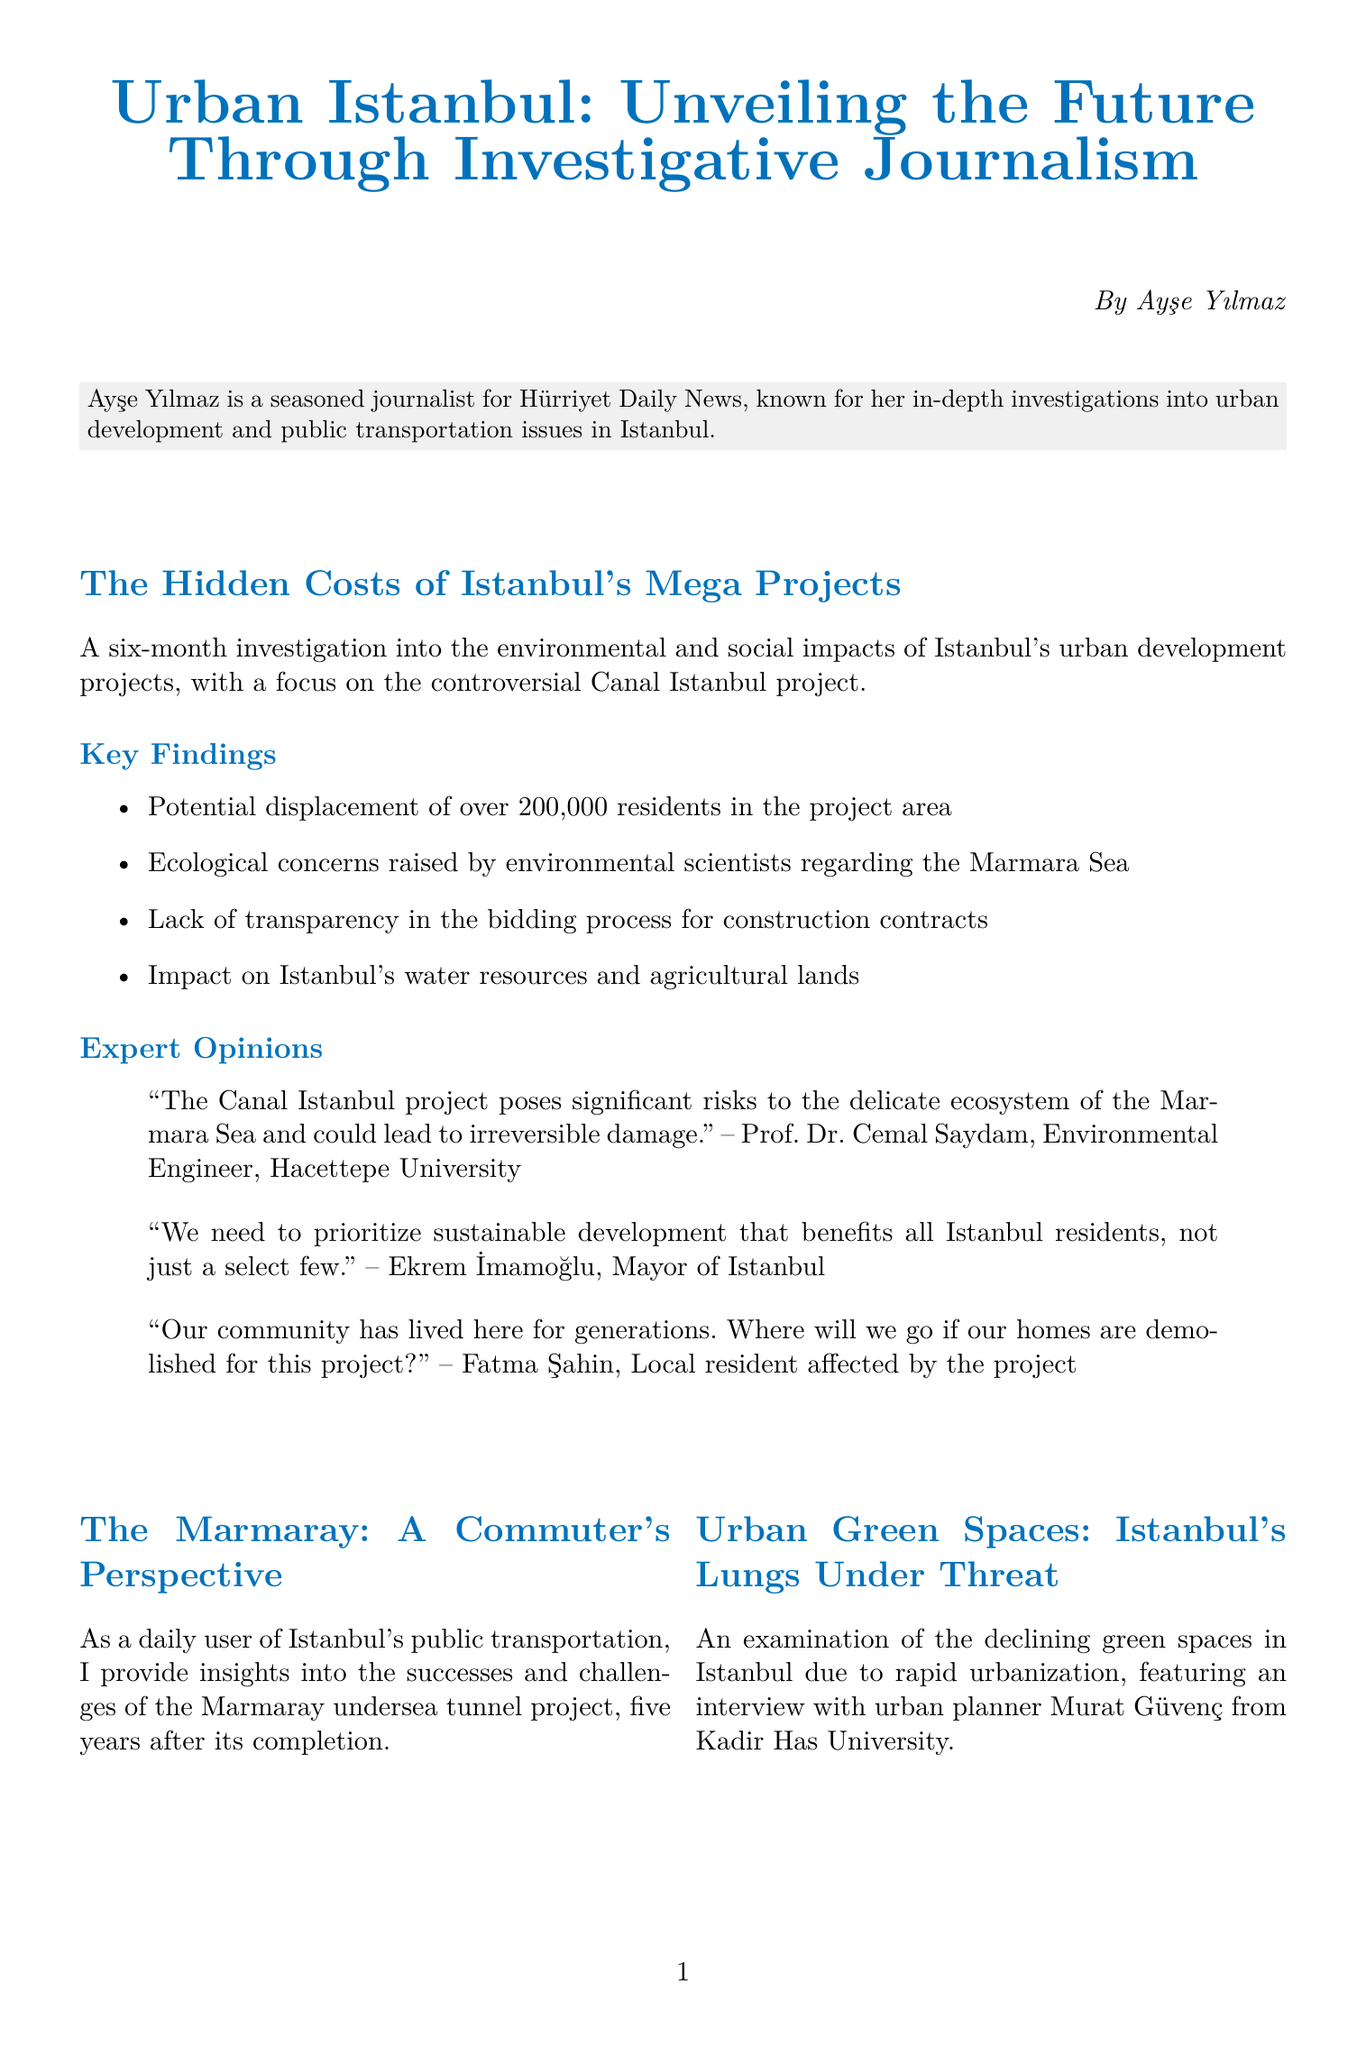what is the title of the newsletter? The title of the newsletter is mentioned at the beginning of the document.
Answer: Urban Istanbul: Unveiling the Future Through Investigative Journalism who authored the main article? The author of the main article is stated below the title.
Answer: Ayşe Yılmaz how many residents may be displaced by the Canal Istanbul project? This information is found in the key findings section of the main article.
Answer: over 200,000 residents what ecological concern is highlighted by environmental scientists? The concerns regarding the ecology are specified under the key findings.
Answer: Marmara Sea who is the Mayor of Istanbul? The Mayor of Istanbul is referenced in the expert opinions section.
Answer: Ekrem İmamoğlu what type of project is the Marmaray? This type of project is described in the sidebar feature about the commuter's perspective.
Answer: undersea tunnel which university is Prof. Dr. Cemal Saydam affiliated with? This information can be found in the expert opinions section.
Answer: Hacettepe University what is the main theme of the upcoming webinar? The theme of the webinar is presented in the call-to-action section.
Answer: Sustainable Urban Development in Istanbul how many main articles are included in the newsletter? The document lists the main article and two sidebar features, counting the features as separate articles.
Answer: one main article 